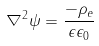<formula> <loc_0><loc_0><loc_500><loc_500>\nabla ^ { 2 } \psi = \frac { - \rho _ { e } } { \epsilon \epsilon _ { 0 } }</formula> 